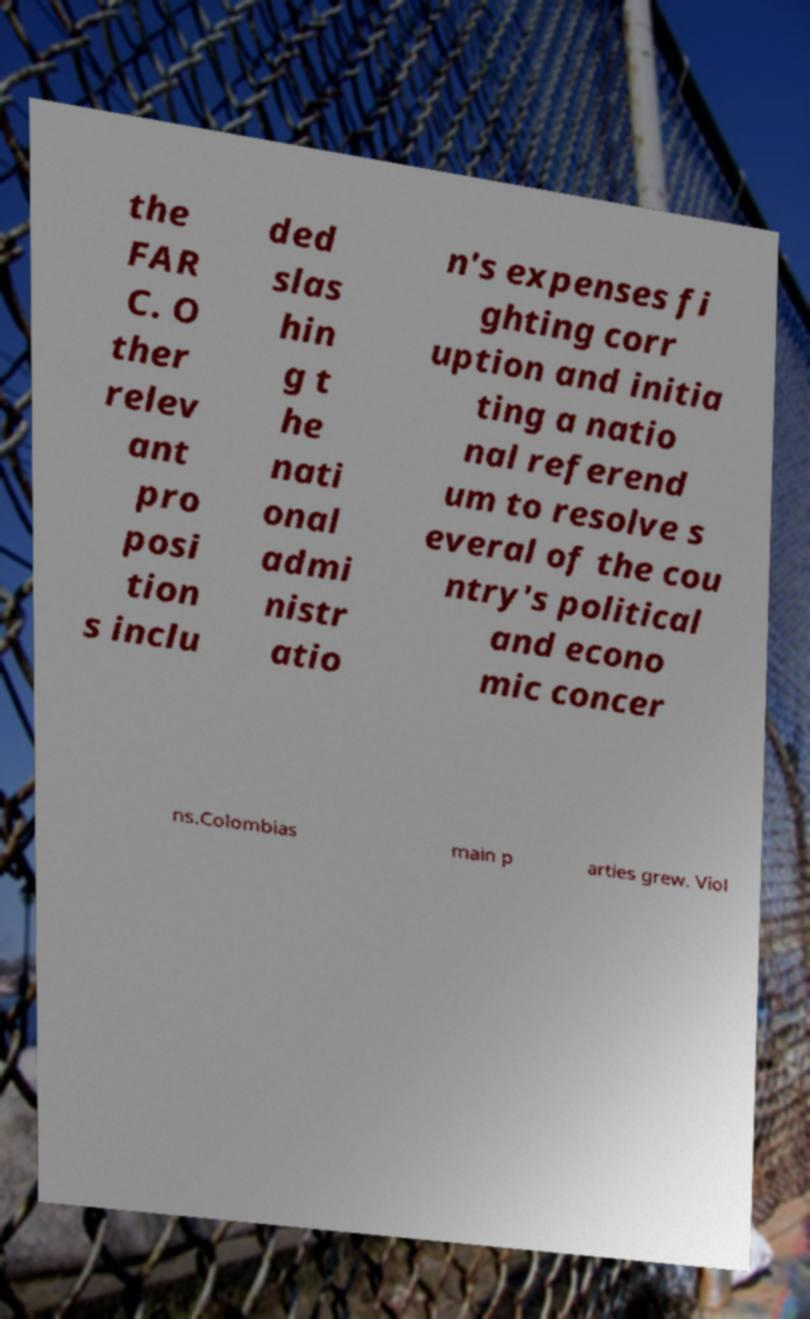What messages or text are displayed in this image? I need them in a readable, typed format. the FAR C. O ther relev ant pro posi tion s inclu ded slas hin g t he nati onal admi nistr atio n's expenses fi ghting corr uption and initia ting a natio nal referend um to resolve s everal of the cou ntry's political and econo mic concer ns.Colombias main p arties grew. Viol 